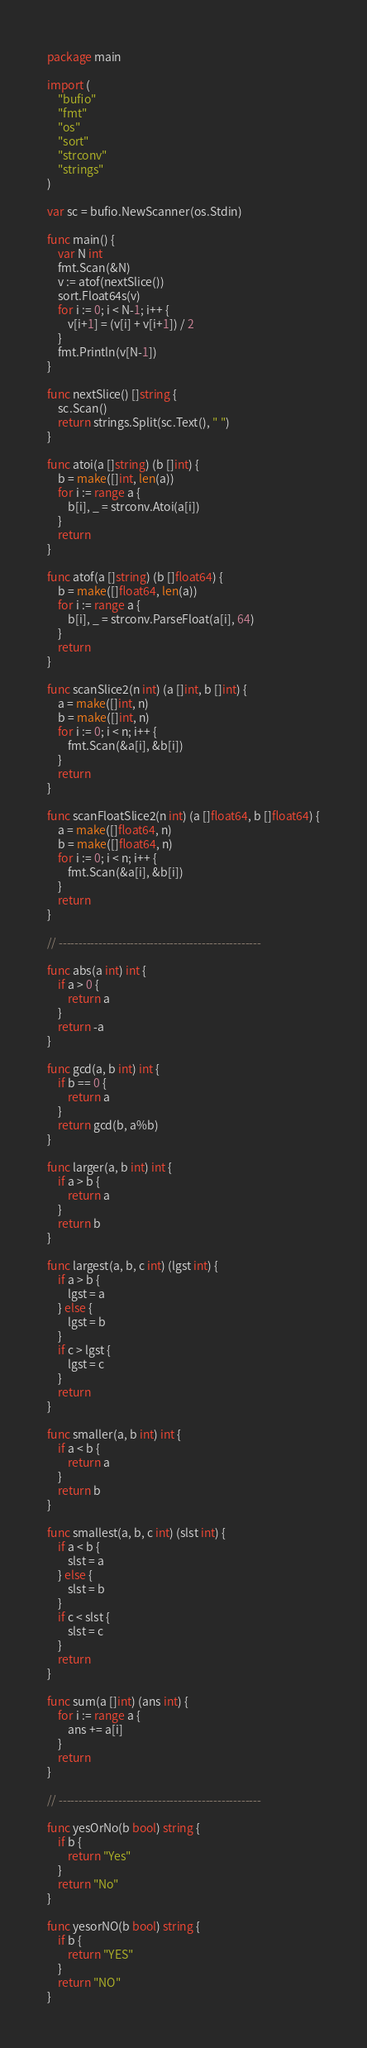<code> <loc_0><loc_0><loc_500><loc_500><_Go_>package main

import (
	"bufio"
	"fmt"
	"os"
	"sort"
	"strconv"
	"strings"
)

var sc = bufio.NewScanner(os.Stdin)

func main() {
	var N int
	fmt.Scan(&N)
	v := atof(nextSlice())
	sort.Float64s(v)
	for i := 0; i < N-1; i++ {
		v[i+1] = (v[i] + v[i+1]) / 2
	}
	fmt.Println(v[N-1])
}

func nextSlice() []string {
	sc.Scan()
	return strings.Split(sc.Text(), " ")
}

func atoi(a []string) (b []int) {
	b = make([]int, len(a))
	for i := range a {
		b[i], _ = strconv.Atoi(a[i])
	}
	return
}

func atof(a []string) (b []float64) {
	b = make([]float64, len(a))
	for i := range a {
		b[i], _ = strconv.ParseFloat(a[i], 64)
	}
	return
}

func scanSlice2(n int) (a []int, b []int) {
	a = make([]int, n)
	b = make([]int, n)
	for i := 0; i < n; i++ {
		fmt.Scan(&a[i], &b[i])
	}
	return
}

func scanFloatSlice2(n int) (a []float64, b []float64) {
	a = make([]float64, n)
	b = make([]float64, n)
	for i := 0; i < n; i++ {
		fmt.Scan(&a[i], &b[i])
	}
	return
}

// ---------------------------------------------------

func abs(a int) int {
	if a > 0 {
		return a
	}
	return -a
}

func gcd(a, b int) int {
	if b == 0 {
		return a
	}
	return gcd(b, a%b)
}

func larger(a, b int) int {
	if a > b {
		return a
	}
	return b
}

func largest(a, b, c int) (lgst int) {
	if a > b {
		lgst = a
	} else {
		lgst = b
	}
	if c > lgst {
		lgst = c
	}
	return
}

func smaller(a, b int) int {
	if a < b {
		return a
	}
	return b
}

func smallest(a, b, c int) (slst int) {
	if a < b {
		slst = a
	} else {
		slst = b
	}
	if c < slst {
		slst = c
	}
	return
}

func sum(a []int) (ans int) {
	for i := range a {
		ans += a[i]
	}
	return
}

// ---------------------------------------------------

func yesOrNo(b bool) string {
	if b {
		return "Yes"
	}
	return "No"
}

func yesorNO(b bool) string {
	if b {
		return "YES"
	}
	return "NO"
}</code> 